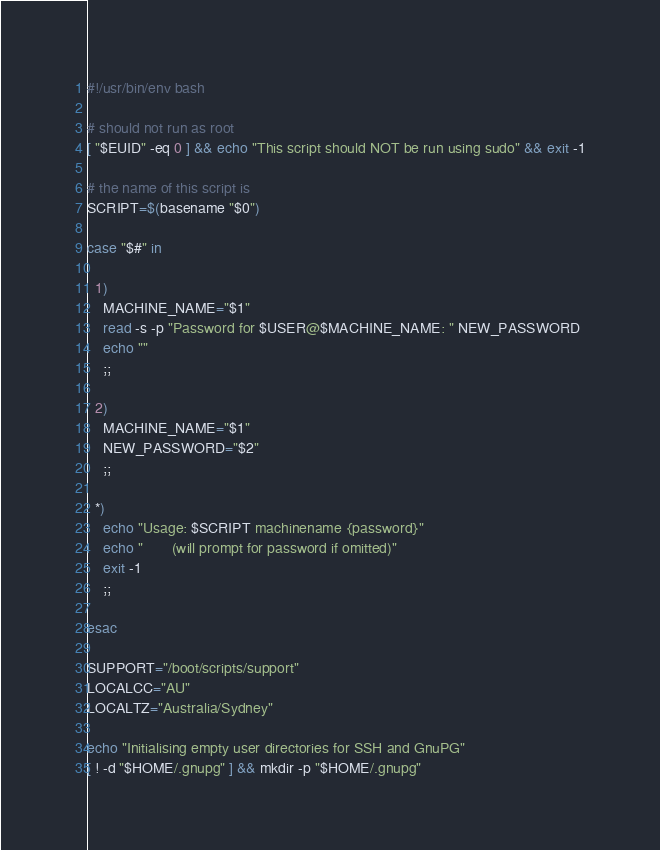<code> <loc_0><loc_0><loc_500><loc_500><_Bash_>#!/usr/bin/env bash

# should not run as root
[ "$EUID" -eq 0 ] && echo "This script should NOT be run using sudo" && exit -1

# the name of this script is
SCRIPT=$(basename "$0")

case "$#" in

  1)
    MACHINE_NAME="$1"
    read -s -p "Password for $USER@$MACHINE_NAME: " NEW_PASSWORD
    echo ""
    ;;

  2)
    MACHINE_NAME="$1"
    NEW_PASSWORD="$2"
    ;;

  *)
    echo "Usage: $SCRIPT machinename {password}"
    echo "       (will prompt for password if omitted)"
    exit -1
    ;;

esac

SUPPORT="/boot/scripts/support"
LOCALCC="AU"
LOCALTZ="Australia/Sydney"

echo "Initialising empty user directories for SSH and GnuPG"
[ ! -d "$HOME/.gnupg" ] && mkdir -p "$HOME/.gnupg"</code> 